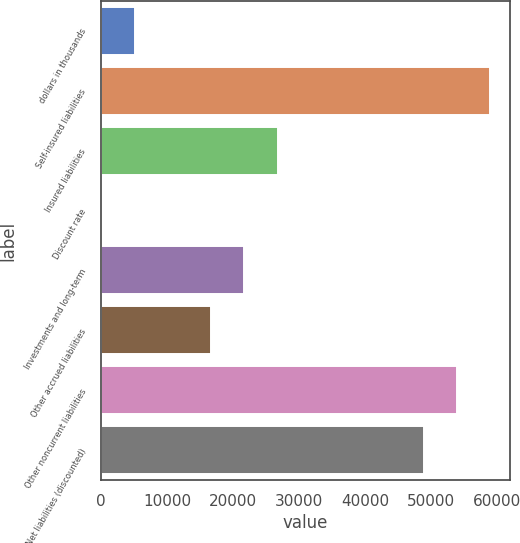<chart> <loc_0><loc_0><loc_500><loc_500><bar_chart><fcel>dollars in thousands<fcel>Self-insured liabilities<fcel>Insured liabilities<fcel>Discount rate<fcel>Investments and long-term<fcel>Other accrued liabilities<fcel>Other noncurrent liabilities<fcel>Net liabilities (discounted)<nl><fcel>5054.68<fcel>58995.4<fcel>26764.4<fcel>0.98<fcel>21710.7<fcel>16657<fcel>53941.7<fcel>48888<nl></chart> 